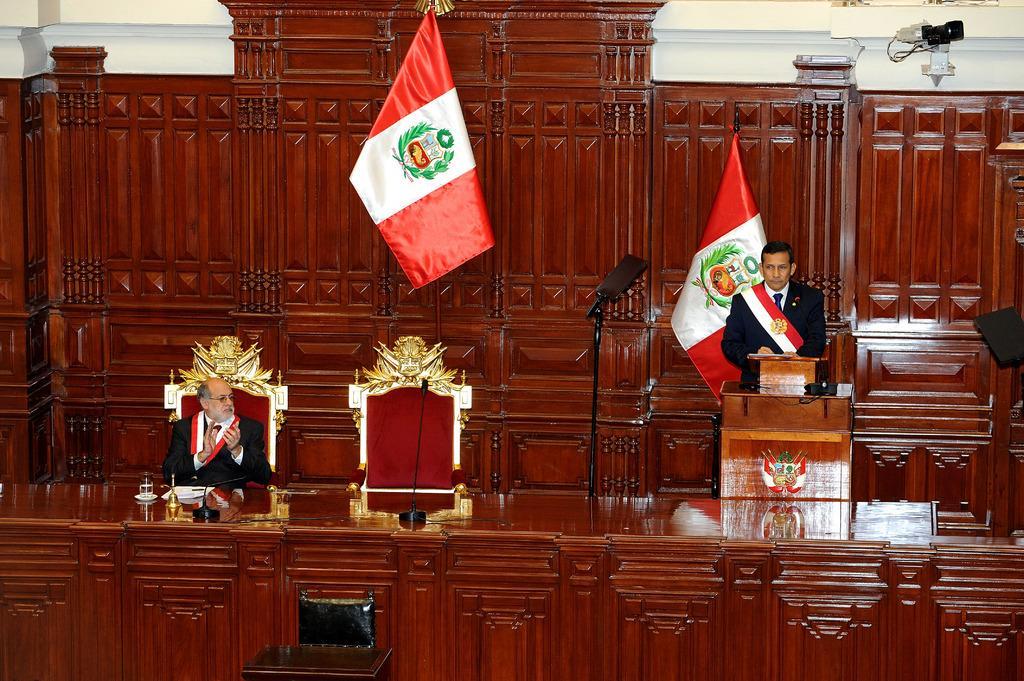In one or two sentences, can you explain what this image depicts? In this picture we can see a man is sitting on a chair and another person is standing behind the podium. In front of the man it is looking like a wooden table and on the table there are microphones, glass, sauce and papers. On the left side of the man there is a stand and a chair. Behind the people there are flags, wooden wall and an object. 